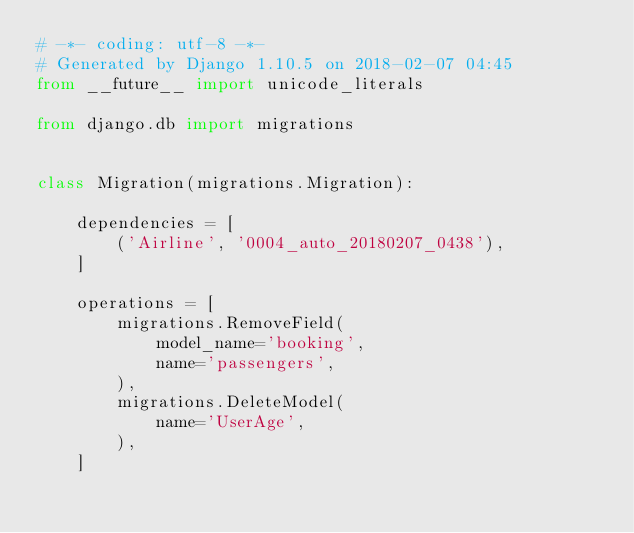<code> <loc_0><loc_0><loc_500><loc_500><_Python_># -*- coding: utf-8 -*-
# Generated by Django 1.10.5 on 2018-02-07 04:45
from __future__ import unicode_literals

from django.db import migrations


class Migration(migrations.Migration):

    dependencies = [
        ('Airline', '0004_auto_20180207_0438'),
    ]

    operations = [
        migrations.RemoveField(
            model_name='booking',
            name='passengers',
        ),
        migrations.DeleteModel(
            name='UserAge',
        ),
    ]
</code> 